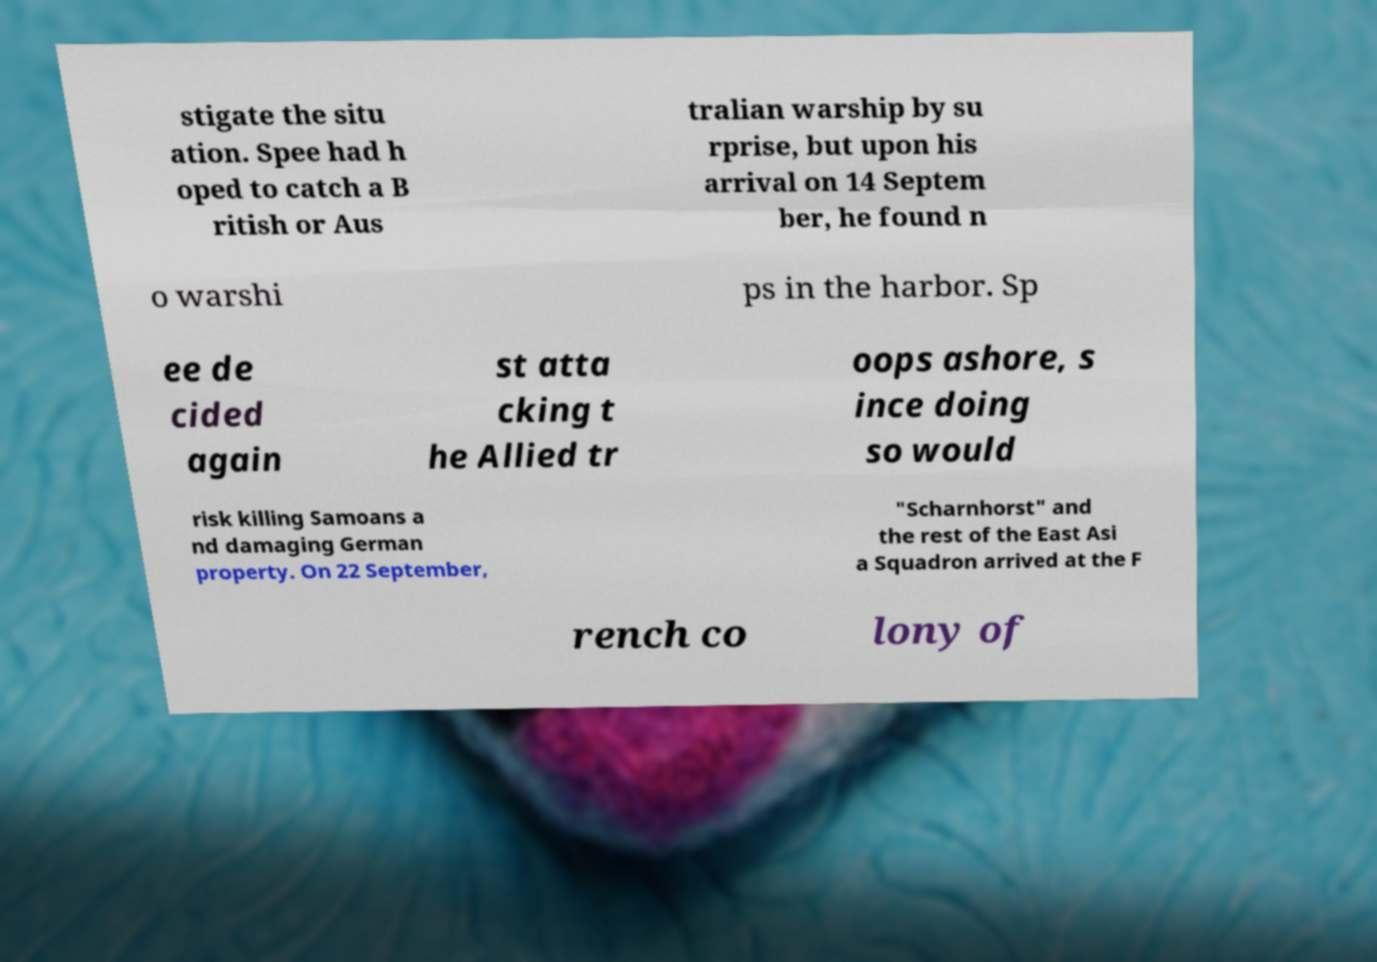What messages or text are displayed in this image? I need them in a readable, typed format. stigate the situ ation. Spee had h oped to catch a B ritish or Aus tralian warship by su rprise, but upon his arrival on 14 Septem ber, he found n o warshi ps in the harbor. Sp ee de cided again st atta cking t he Allied tr oops ashore, s ince doing so would risk killing Samoans a nd damaging German property. On 22 September, "Scharnhorst" and the rest of the East Asi a Squadron arrived at the F rench co lony of 